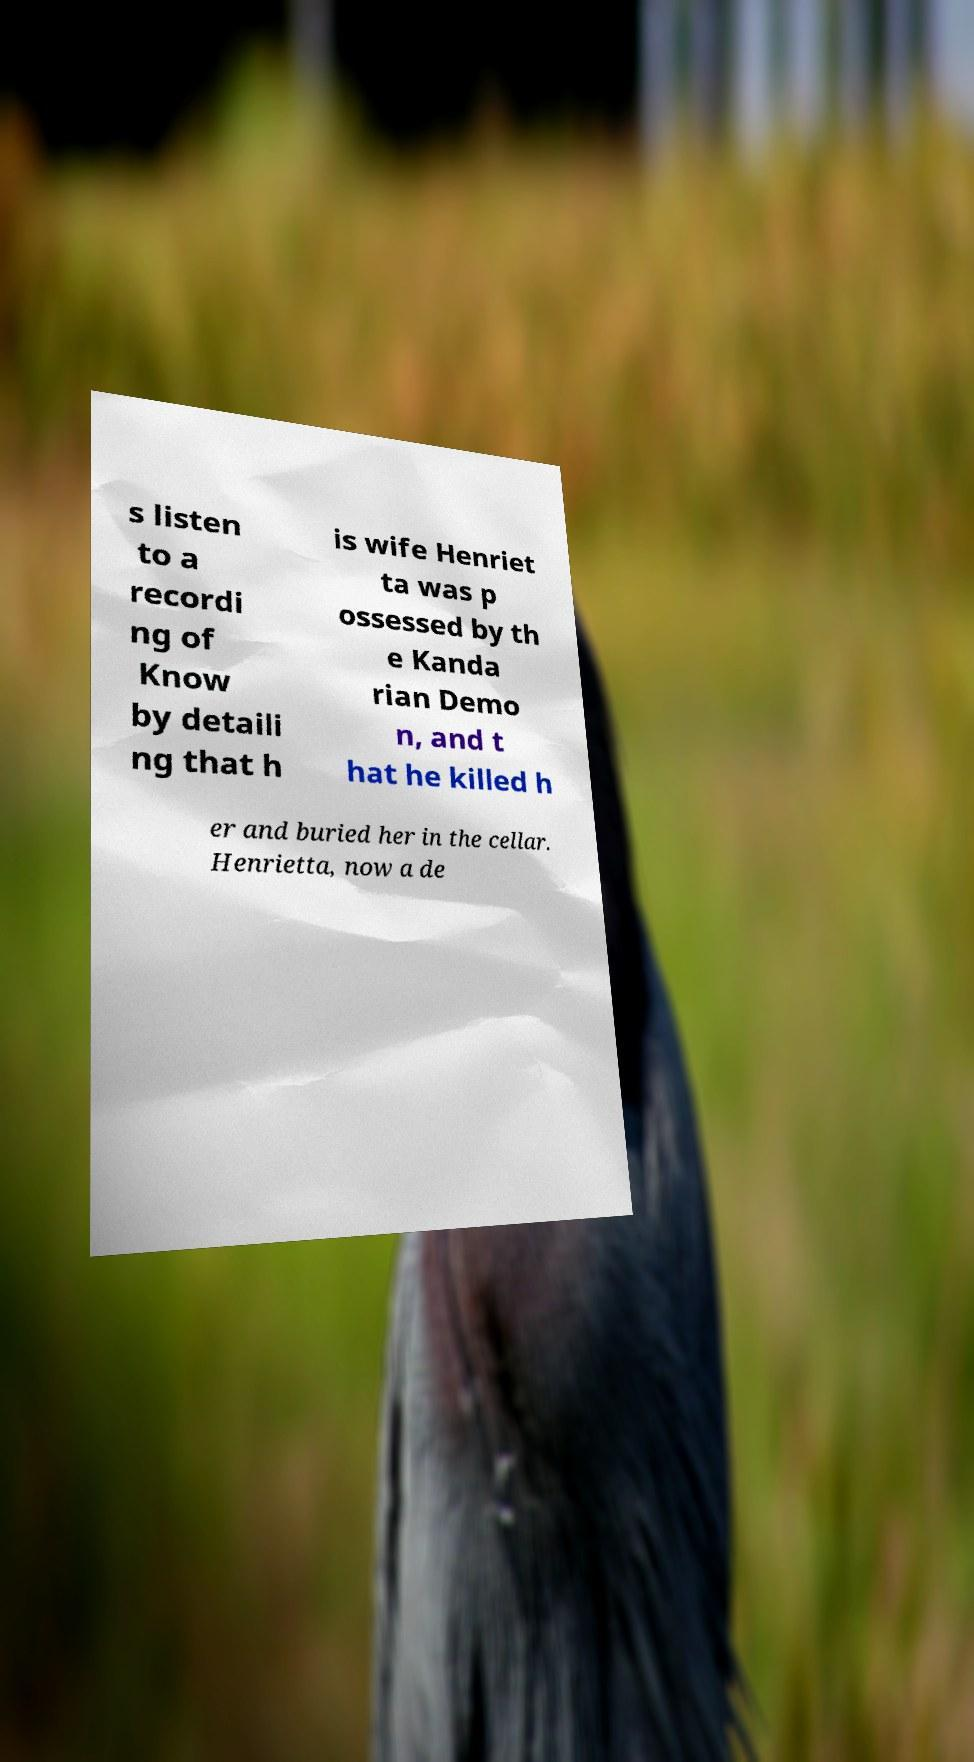Please identify and transcribe the text found in this image. s listen to a recordi ng of Know by detaili ng that h is wife Henriet ta was p ossessed by th e Kanda rian Demo n, and t hat he killed h er and buried her in the cellar. Henrietta, now a de 